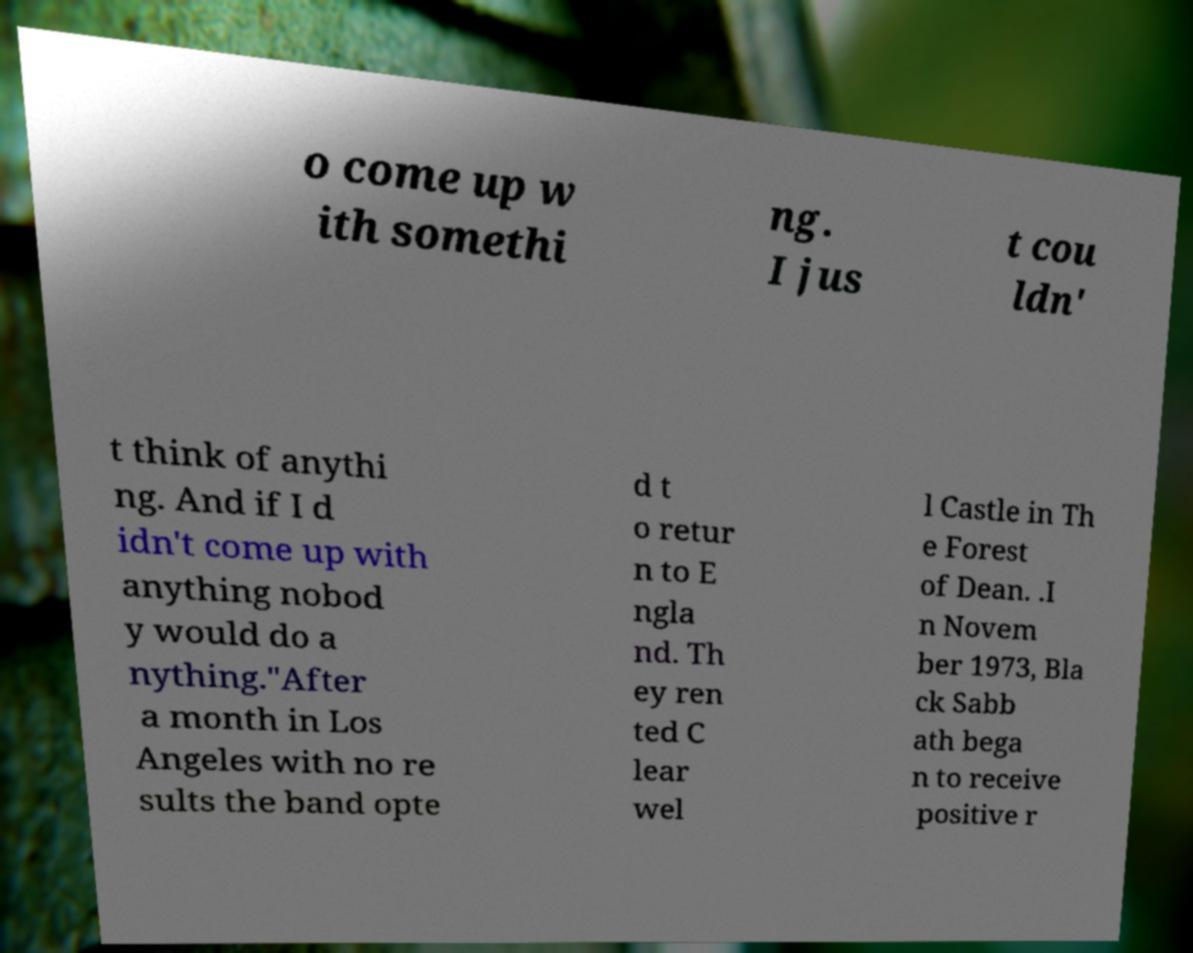Can you accurately transcribe the text from the provided image for me? o come up w ith somethi ng. I jus t cou ldn' t think of anythi ng. And if I d idn't come up with anything nobod y would do a nything."After a month in Los Angeles with no re sults the band opte d t o retur n to E ngla nd. Th ey ren ted C lear wel l Castle in Th e Forest of Dean. .I n Novem ber 1973, Bla ck Sabb ath bega n to receive positive r 